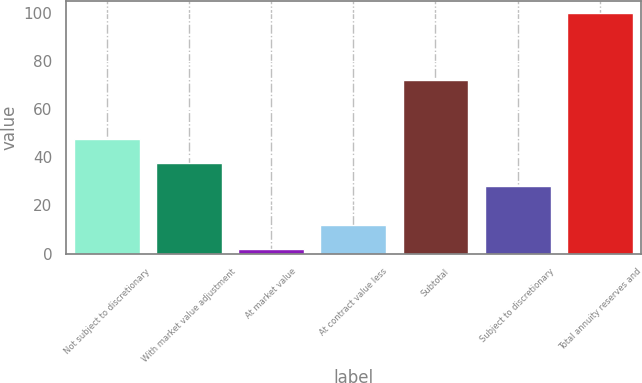<chart> <loc_0><loc_0><loc_500><loc_500><bar_chart><fcel>Not subject to discretionary<fcel>With market value adjustment<fcel>At market value<fcel>At contract value less<fcel>Subtotal<fcel>Subject to discretionary<fcel>Total annuity reserves and<nl><fcel>47.6<fcel>37.8<fcel>2<fcel>11.8<fcel>72<fcel>28<fcel>100<nl></chart> 